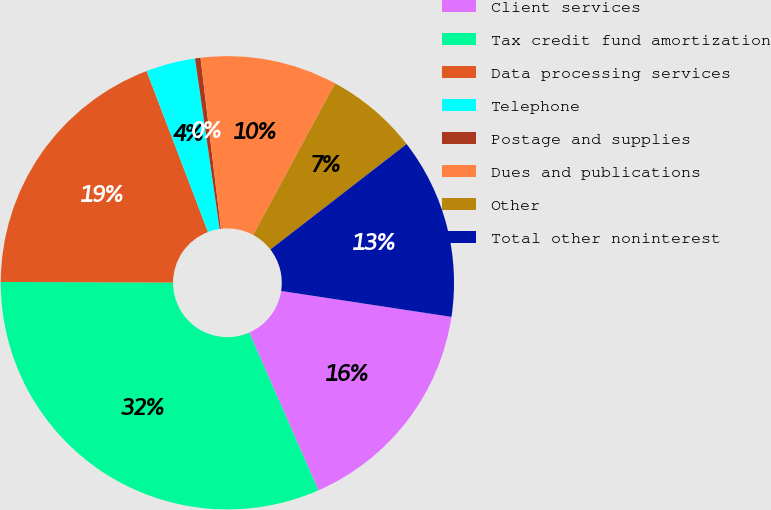Convert chart to OTSL. <chart><loc_0><loc_0><loc_500><loc_500><pie_chart><fcel>Client services<fcel>Tax credit fund amortization<fcel>Data processing services<fcel>Telephone<fcel>Postage and supplies<fcel>Dues and publications<fcel>Other<fcel>Total other noninterest<nl><fcel>16.02%<fcel>31.64%<fcel>19.14%<fcel>3.52%<fcel>0.39%<fcel>9.77%<fcel>6.64%<fcel>12.89%<nl></chart> 